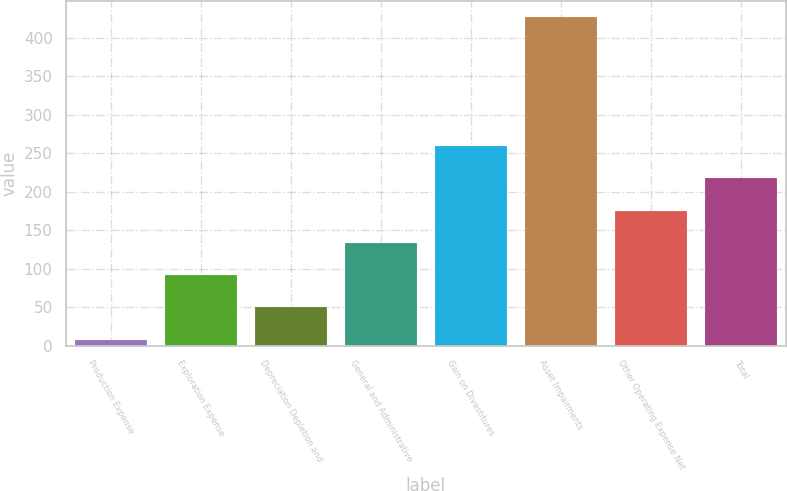Convert chart. <chart><loc_0><loc_0><loc_500><loc_500><bar_chart><fcel>Production Expense<fcel>Exploration Expense<fcel>Depreciation Depletion and<fcel>General and Administrative<fcel>Gain on Divestitures<fcel>Asset Impairments<fcel>Other Operating Expense Net<fcel>Total<nl><fcel>8<fcel>91.8<fcel>49.9<fcel>133.7<fcel>259.4<fcel>427<fcel>175.6<fcel>217.5<nl></chart> 